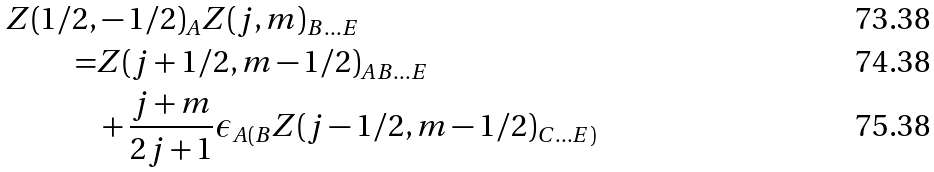Convert formula to latex. <formula><loc_0><loc_0><loc_500><loc_500>Z ( 1 / 2 , & - 1 / 2 ) _ { A } Z ( j , m ) _ { B \dots E } \\ = & Z ( j + 1 / 2 , m - 1 / 2 ) _ { A B \dots E } \\ & + \frac { j + m } { 2 j + 1 } \epsilon _ { A ( B } Z ( j - 1 / 2 , m - 1 / 2 ) _ { C \dots E ) }</formula> 